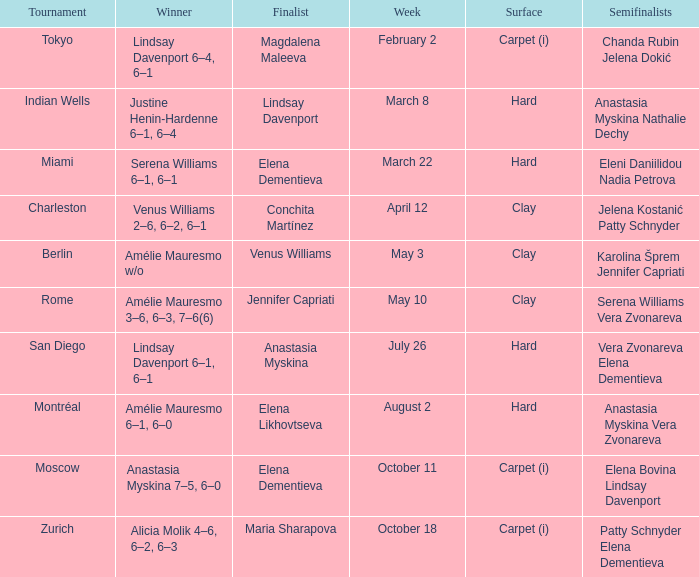Who was the winner of the Miami tournament where Elena Dementieva was a finalist? Serena Williams 6–1, 6–1. 